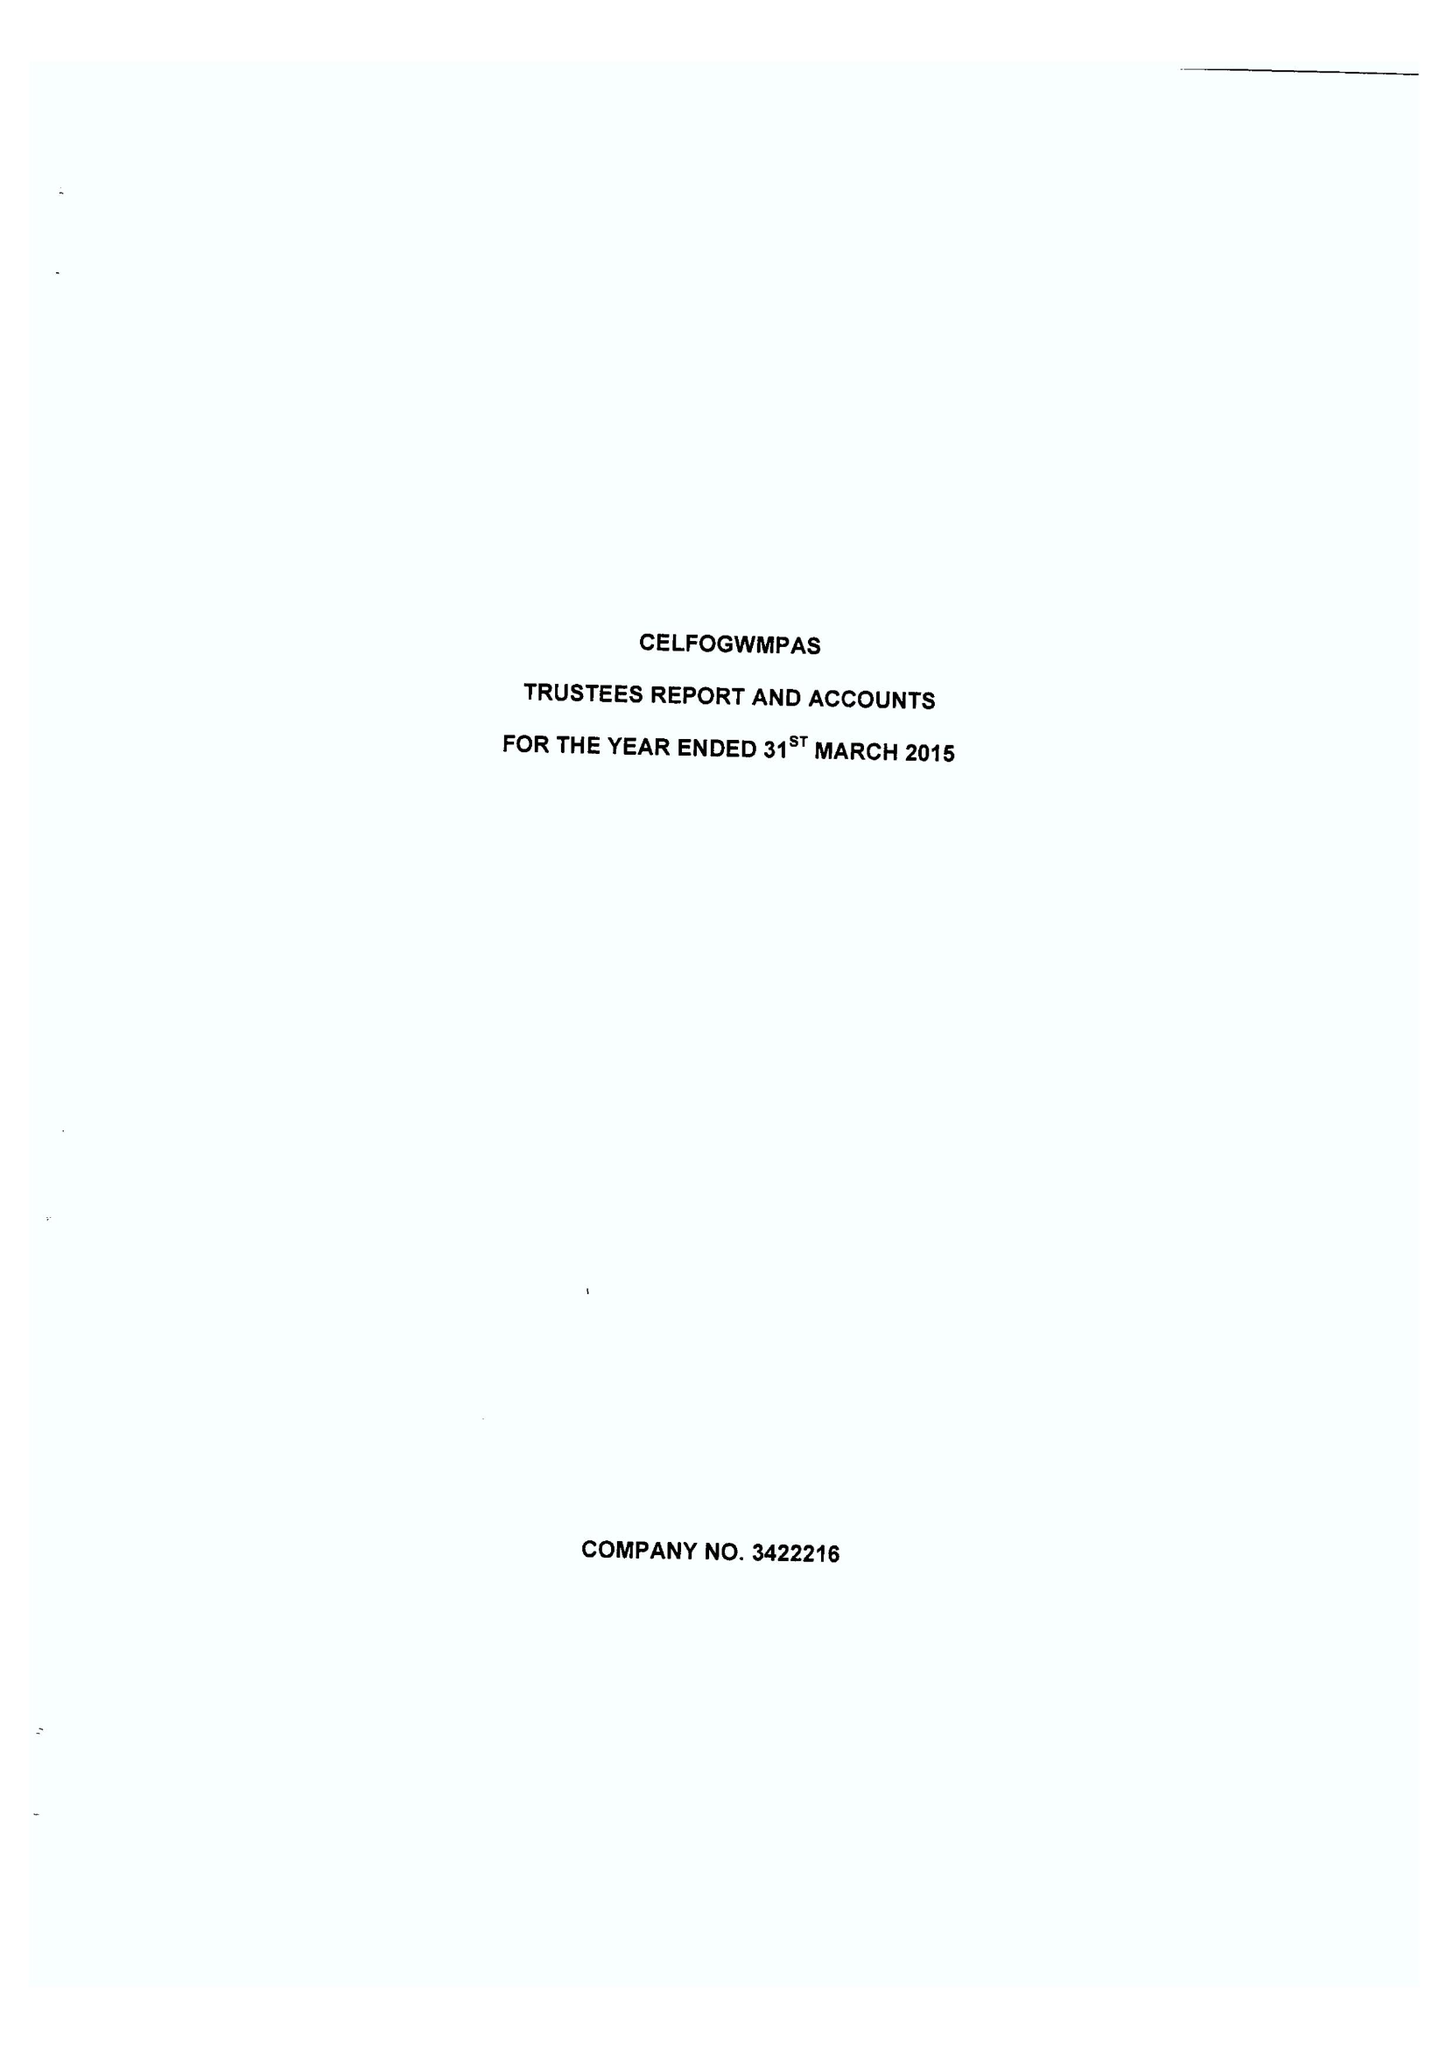What is the value for the address__postcode?
Answer the question using a single word or phrase. LD1 5EB 